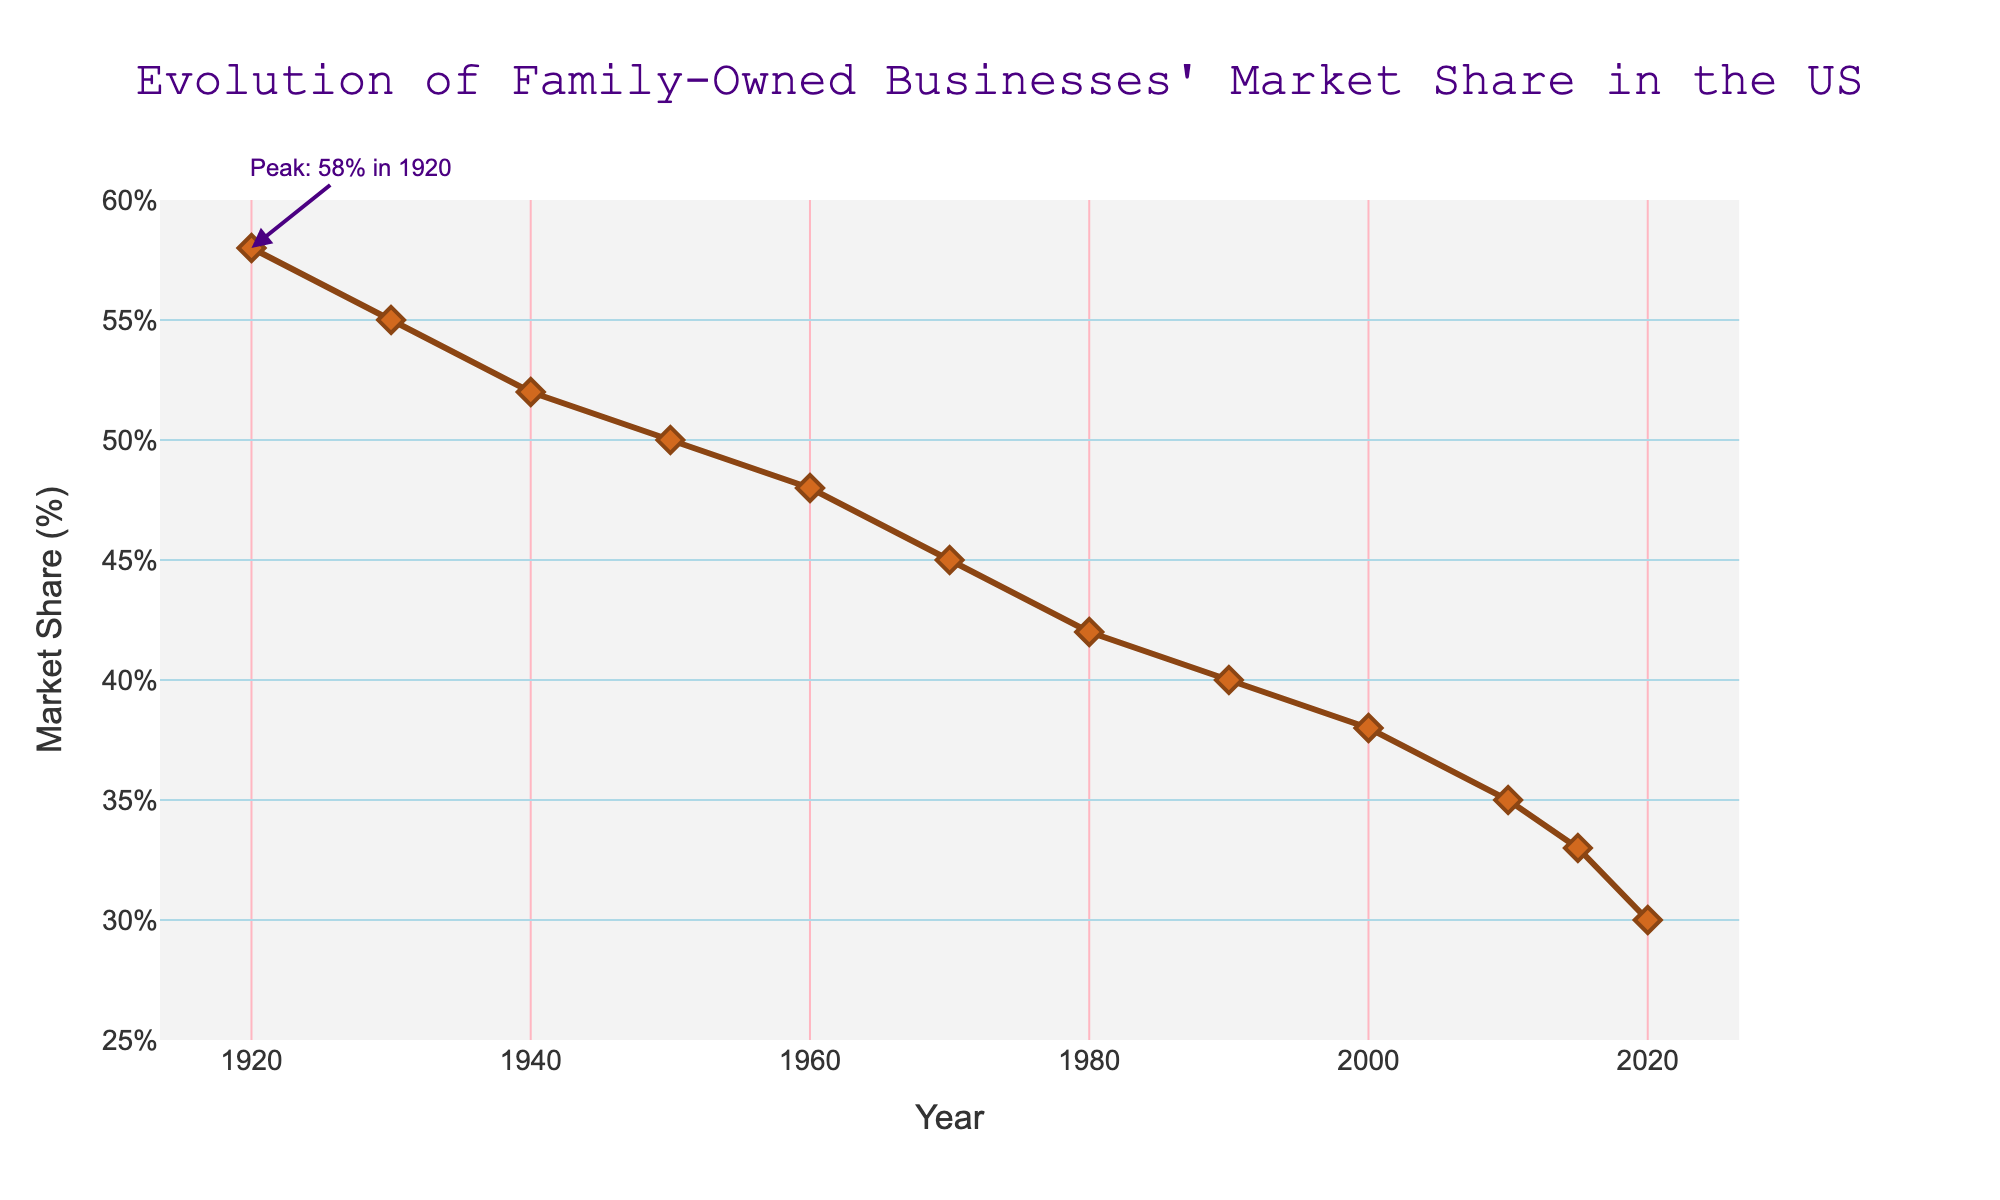What was the market share of family-owned businesses in 1940? From the figure, find the point corresponding to the year 1940 on the x-axis and note the market share value on the y-axis.
Answer: 52% How much did the market share of family-owned businesses decrease from 1920 to 2020? From the figure, subtract the market share value in 2020 (30%) from the value in 1920 (58%). The calculation is 58% - 30% = 28%.
Answer: 28% In which decade did the market share of family-owned businesses drop below 40%? From the figure, observe the trend line and identify the decade when the market share first drops below 40%. This occurs between 1980 to 1990.
Answer: 1980 to 1990 What is the total market share decrease over the entire 100-year period shown in the figure? From the figure, subtract the market share value in 2020 (30%) from the value in 1920 (58%). The calculation is 58% - 30% = 28%.
Answer: 28% What is the average market share of family-owned businesses between 1950 and 2000? From the figure, note the market share values for the years 1950, 1960, 1970, 1980, 1990, and 2000. Add these values and divide by the number of years: (50 + 48 + 45 + 42 + 40 + 38) / 6 = 43.83%.
Answer: 43.83% Which visual cue is used to highlight the peak market share in 1920? From the figure, note the use of an annotation pointing to the year 1920 with the text "Peak: 58% in 1920" and an arrow indicating this point.
Answer: Annotation and arrow How does the steepness of the decline from 1960 to 1980 compare to the steepness from 2000 to 2020? From the figure, visually compare the slopes of the segments between 1960-1980 and 2000-2020. The decline from 2000 to 2020 appears steeper than the decline from 1960 to 1980, indicating a faster rate of market share reduction in the latter period.
Answer: 2000 to 2020 is steeper What is the median market share value over the 100-year period? From the figure, list the market share values: 58%, 55%, 52%, 50%, 48%, 45%, 42%, 40%, 38%, 35%, 33%, 30%. The median is the middle value, so arrange them in ascending order and find the middle value: (58, 55, 52, 50, 48, 45, 42, 40, 38, 35, 33, 30). The median value is 45%.
Answer: 45% Between which decades did the market share of family-owned businesses have the smallest decrease? From the figure, observe the trend line between each pair of decades and identify the interval with the smallest difference. The smallest decrease occurs between 2010 and 2015.
Answer: 2010-2015 